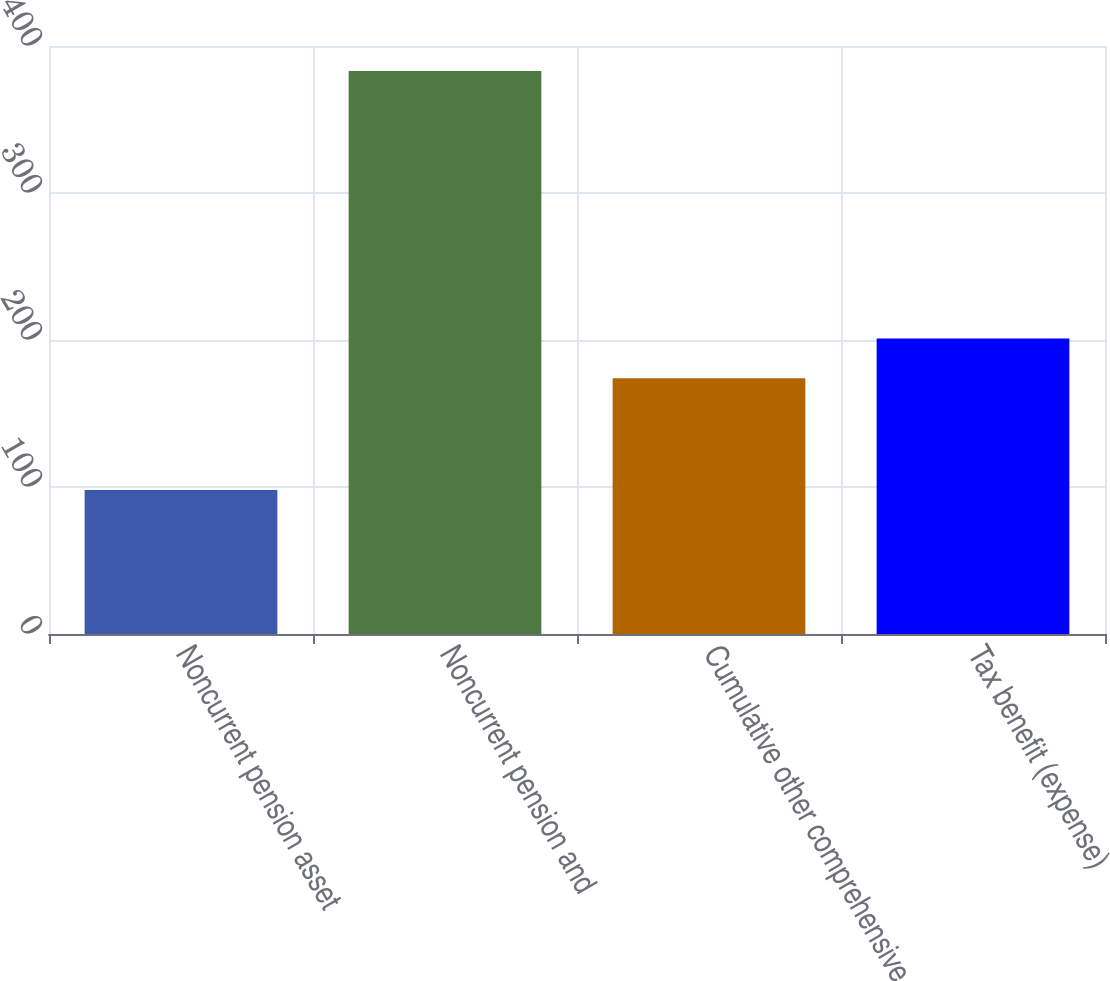Convert chart. <chart><loc_0><loc_0><loc_500><loc_500><bar_chart><fcel>Noncurrent pension asset<fcel>Noncurrent pension and<fcel>Cumulative other comprehensive<fcel>Tax benefit (expense)<nl><fcel>98<fcel>383<fcel>174<fcel>201<nl></chart> 